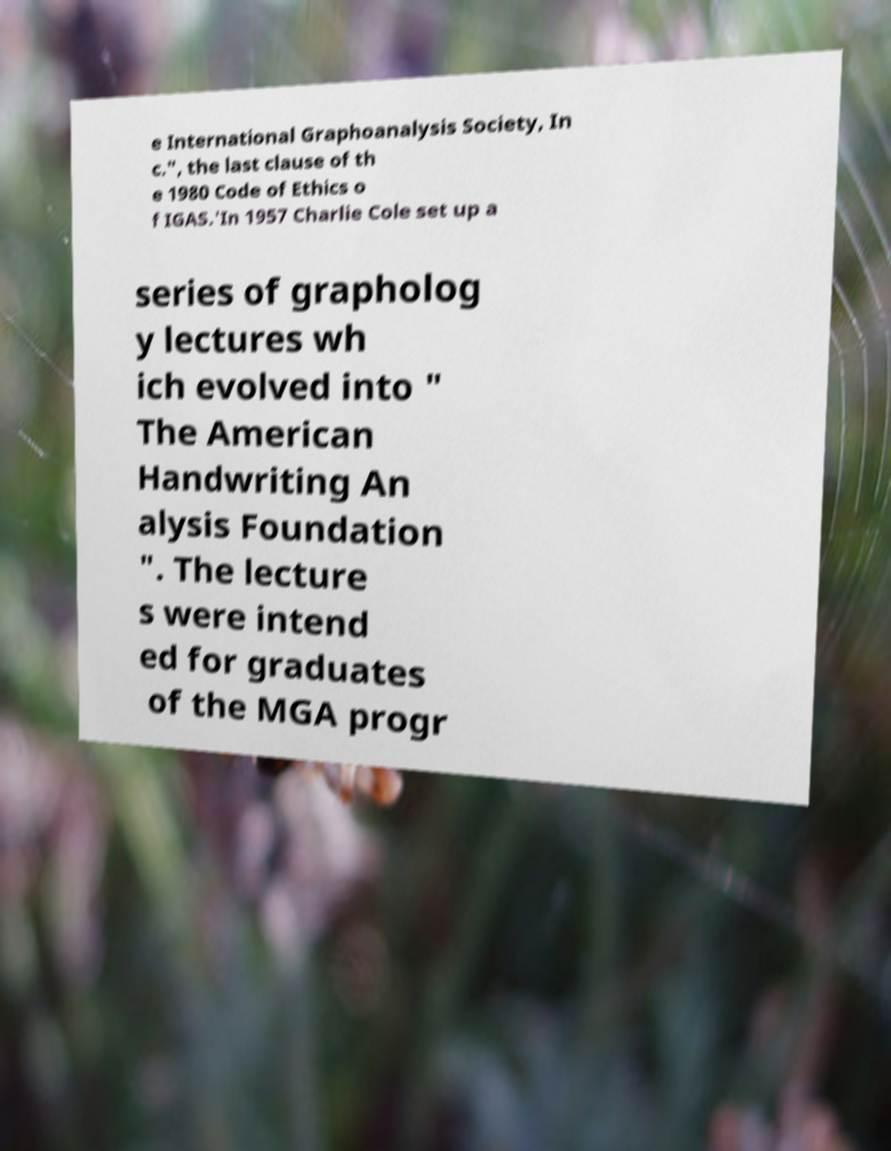Can you accurately transcribe the text from the provided image for me? e International Graphoanalysis Society, In c.", the last clause of th e 1980 Code of Ethics o f IGAS.'In 1957 Charlie Cole set up a series of grapholog y lectures wh ich evolved into " The American Handwriting An alysis Foundation ". The lecture s were intend ed for graduates of the MGA progr 